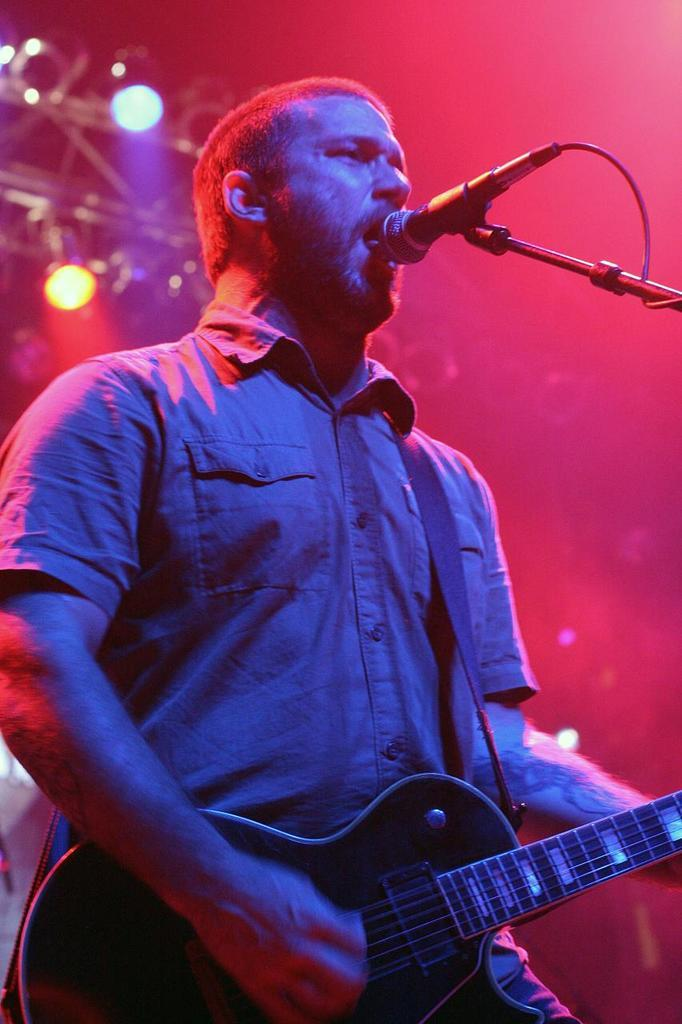What is the person in the image doing? The person is standing and holding a musical instrument. What else is the person doing in the image? The person is singing in front of a microphone. What can be seen in the background of the image? There are multi-color lights in the background of the image. What type of haircut does the person have in the image? There is no information about the person's haircut in the image. 